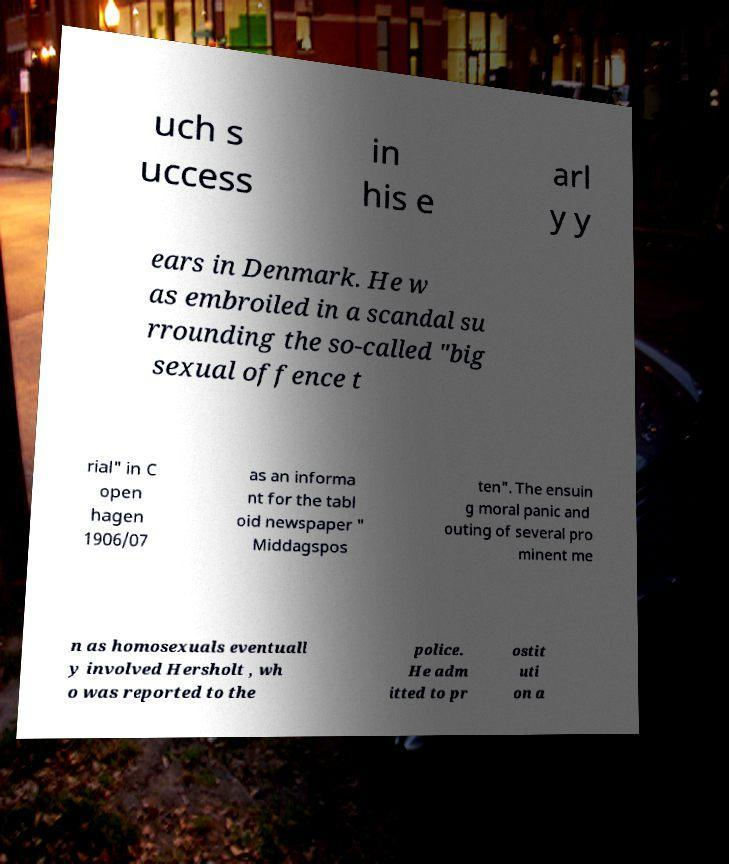Please identify and transcribe the text found in this image. uch s uccess in his e arl y y ears in Denmark. He w as embroiled in a scandal su rrounding the so-called "big sexual offence t rial" in C open hagen 1906/07 as an informa nt for the tabl oid newspaper " Middagspos ten". The ensuin g moral panic and outing of several pro minent me n as homosexuals eventuall y involved Hersholt , wh o was reported to the police. He adm itted to pr ostit uti on a 